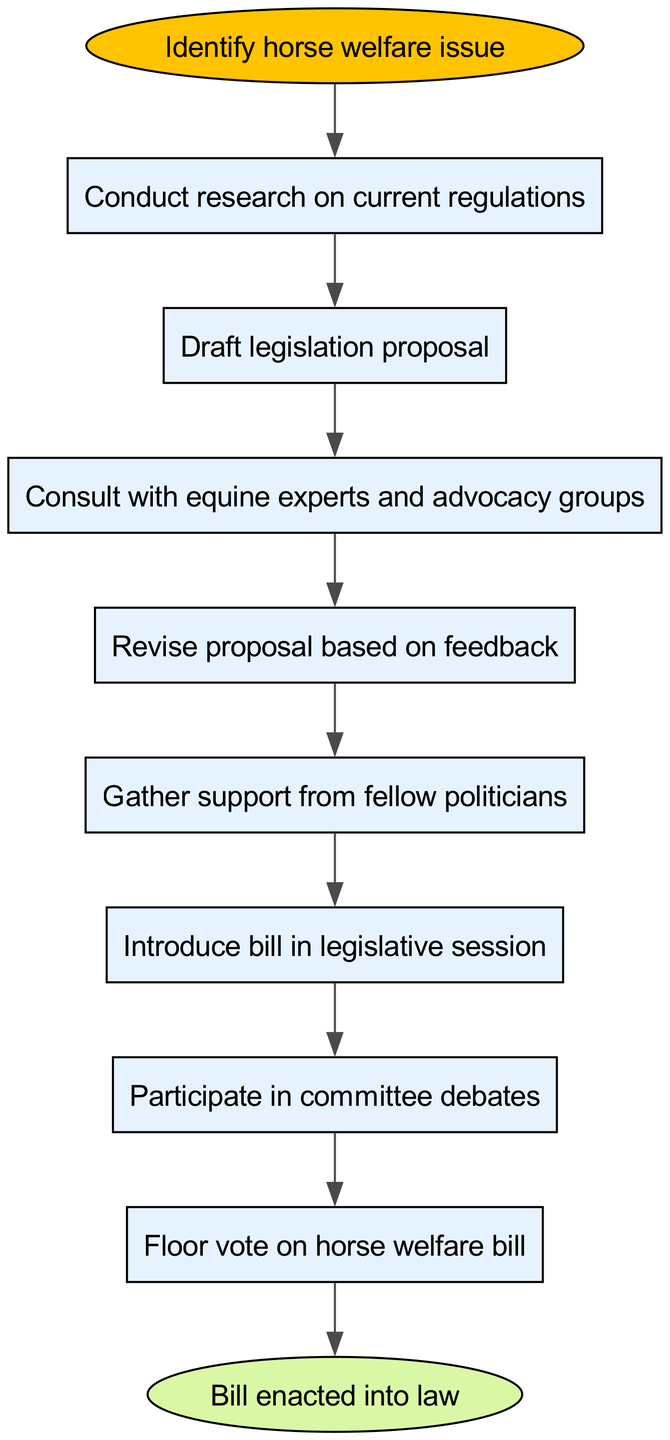What is the first step in the process? The first step in the flow chart is "Identify horse welfare issue," which is indicated at the starting point of the diagram.
Answer: Identify horse welfare issue How many nodes are present in the diagram? The diagram contains 10 nodes, including the start and end nodes. Each of the steps, from identifying the issue to enacting the law, counts as a node.
Answer: 10 What comes after conducting research on current regulations? After "Conduct research on current regulations," the next step in the flow is "Draft legislation proposal," which is indicated by a direct connection from the research node.
Answer: Draft legislation proposal Which node represents the final outcome of the process? The final outcome of the process is represented by the node "Bill enacted into law," which is the last in the sequence of steps leading from the vote node.
Answer: Bill enacted into law What is the last step that follows the floor vote on the horse welfare bill? The last step that follows the "Floor vote on horse welfare bill" is "Bill enacted into law," indicating the successful culmination of the legislative process.
Answer: Bill enacted into law Which steps involve consultation? The steps involving consultation are "Consult with equine experts and advocacy groups" and "Revise proposal based on feedback," as they focus on gathering and incorporating external input.
Answer: Consult with equine experts and advocacy groups; Revise proposal based on feedback How many connections are present in the diagram? There are 9 connections between the nodes in the diagram, signifying the flow from one step to the next within the legislative process.
Answer: 9 What is the relationship between drafting and consulting? The relationship is sequential; after "Draft legislation proposal," the process flows to "Consult with equine experts and advocacy groups," indicating that consultation follows drafting.
Answer: Consult with equine experts and advocacy groups What shape represents the start node? The start node is represented by an ellipse shape, which is a common convention for indicating the beginning of a flowchart process.
Answer: Ellipse 